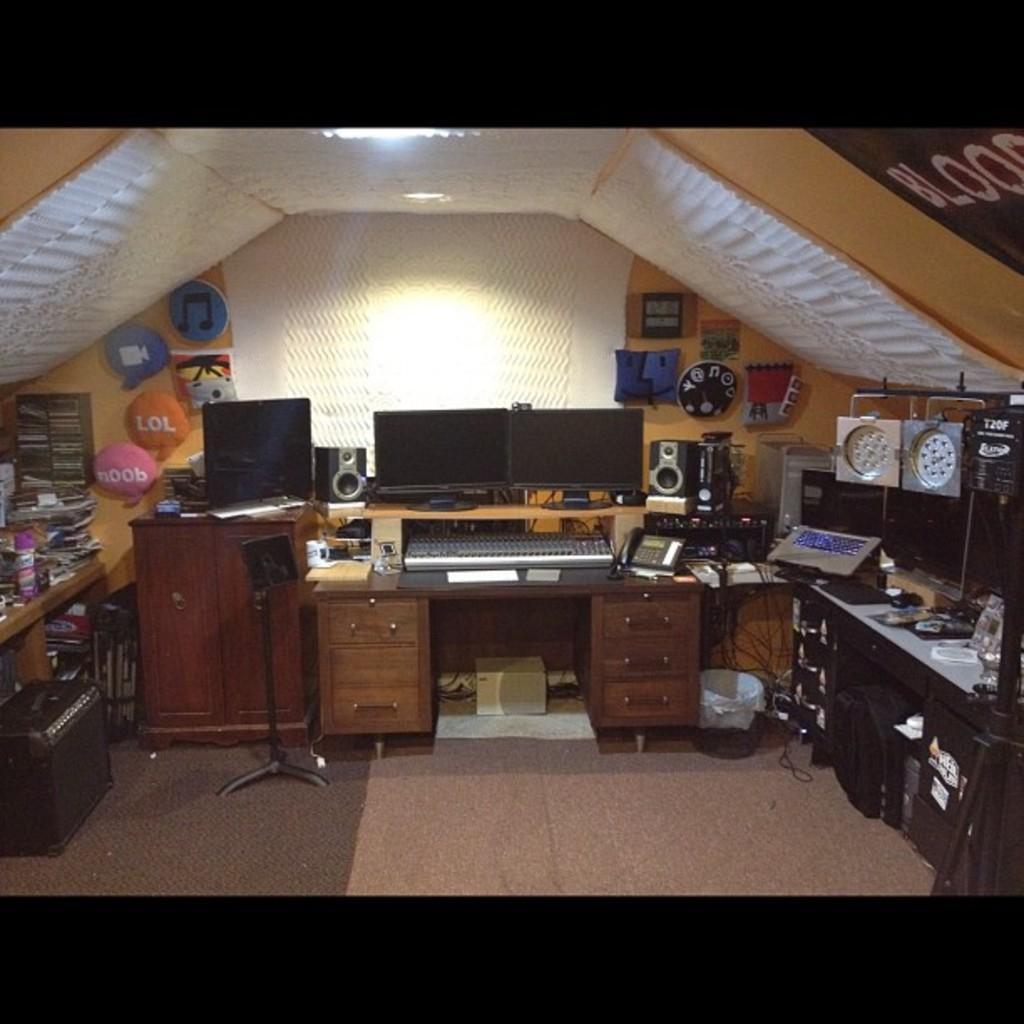Describe this image in one or two sentences. In this image we can see monitors, electronic devices, papers, speakers, telephone and objects on the tables and we can see racks, cupboard doors, objects on the wall, bin, boxes and objects on the floor. 